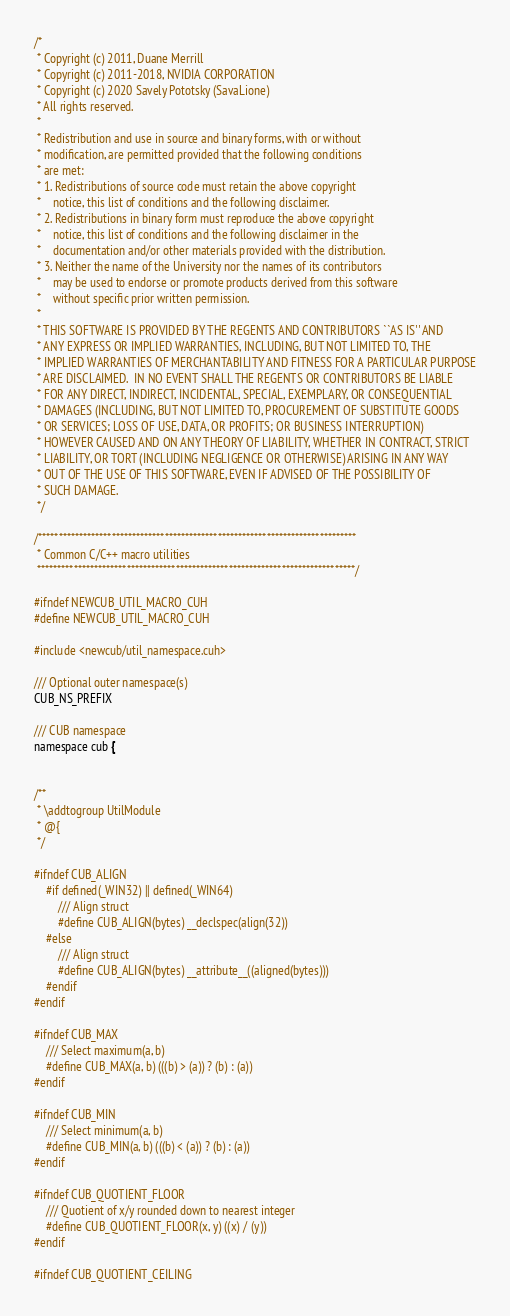<code> <loc_0><loc_0><loc_500><loc_500><_Cuda_>/*
 * Copyright (c) 2011, Duane Merrill
 * Copyright (c) 2011-2018, NVIDIA CORPORATION
 * Copyright (c) 2020 Savely Pototsky (SavaLione)
 * All rights reserved.
 *
 * Redistribution and use in source and binary forms, with or without
 * modification, are permitted provided that the following conditions
 * are met:
 * 1. Redistributions of source code must retain the above copyright
 *    notice, this list of conditions and the following disclaimer.
 * 2. Redistributions in binary form must reproduce the above copyright
 *    notice, this list of conditions and the following disclaimer in the
 *    documentation and/or other materials provided with the distribution.
 * 3. Neither the name of the University nor the names of its contributors
 *    may be used to endorse or promote products derived from this software
 *    without specific prior written permission.
 *
 * THIS SOFTWARE IS PROVIDED BY THE REGENTS AND CONTRIBUTORS ``AS IS'' AND
 * ANY EXPRESS OR IMPLIED WARRANTIES, INCLUDING, BUT NOT LIMITED TO, THE
 * IMPLIED WARRANTIES OF MERCHANTABILITY AND FITNESS FOR A PARTICULAR PURPOSE
 * ARE DISCLAIMED.  IN NO EVENT SHALL THE REGENTS OR CONTRIBUTORS BE LIABLE
 * FOR ANY DIRECT, INDIRECT, INCIDENTAL, SPECIAL, EXEMPLARY, OR CONSEQUENTIAL
 * DAMAGES (INCLUDING, BUT NOT LIMITED TO, PROCUREMENT OF SUBSTITUTE GOODS
 * OR SERVICES; LOSS OF USE, DATA, OR PROFITS; OR BUSINESS INTERRUPTION)
 * HOWEVER CAUSED AND ON ANY THEORY OF LIABILITY, WHETHER IN CONTRACT, STRICT
 * LIABILITY, OR TORT (INCLUDING NEGLIGENCE OR OTHERWISE) ARISING IN ANY WAY
 * OUT OF THE USE OF THIS SOFTWARE, EVEN IF ADVISED OF THE POSSIBILITY OF
 * SUCH DAMAGE.
 */

/******************************************************************************
 * Common C/C++ macro utilities
 ******************************************************************************/

#ifndef NEWCUB_UTIL_MACRO_CUH
#define NEWCUB_UTIL_MACRO_CUH

#include <newcub/util_namespace.cuh>

/// Optional outer namespace(s)
CUB_NS_PREFIX

/// CUB namespace
namespace cub {


/**
 * \addtogroup UtilModule
 * @{
 */

#ifndef CUB_ALIGN
    #if defined(_WIN32) || defined(_WIN64)
        /// Align struct
        #define CUB_ALIGN(bytes) __declspec(align(32))
    #else
        /// Align struct
        #define CUB_ALIGN(bytes) __attribute__((aligned(bytes)))
    #endif
#endif

#ifndef CUB_MAX
    /// Select maximum(a, b)
    #define CUB_MAX(a, b) (((b) > (a)) ? (b) : (a))
#endif

#ifndef CUB_MIN
    /// Select minimum(a, b)
    #define CUB_MIN(a, b) (((b) < (a)) ? (b) : (a))
#endif

#ifndef CUB_QUOTIENT_FLOOR
    /// Quotient of x/y rounded down to nearest integer
    #define CUB_QUOTIENT_FLOOR(x, y) ((x) / (y))
#endif

#ifndef CUB_QUOTIENT_CEILING</code> 